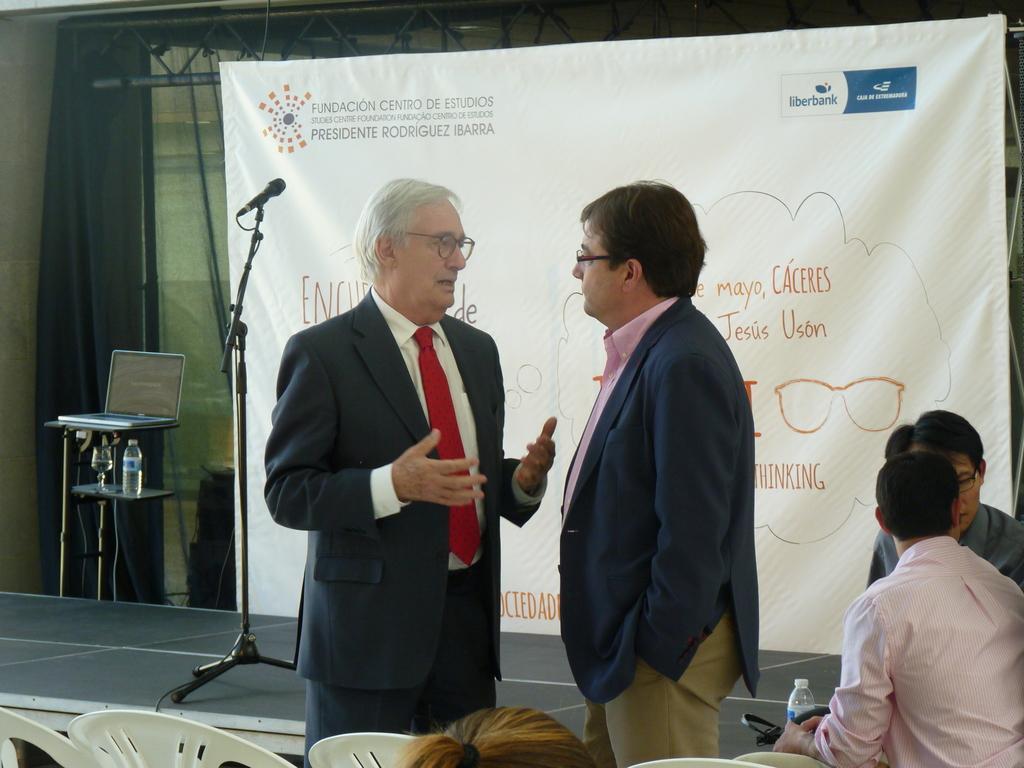Could you give a brief overview of what you see in this image? There are two persons standing on the floor and they wore spectacles. Here we can see two persons are sitting on the chairs. In the background we can see a mike, laptop, bottle, cloth, and a banner. 